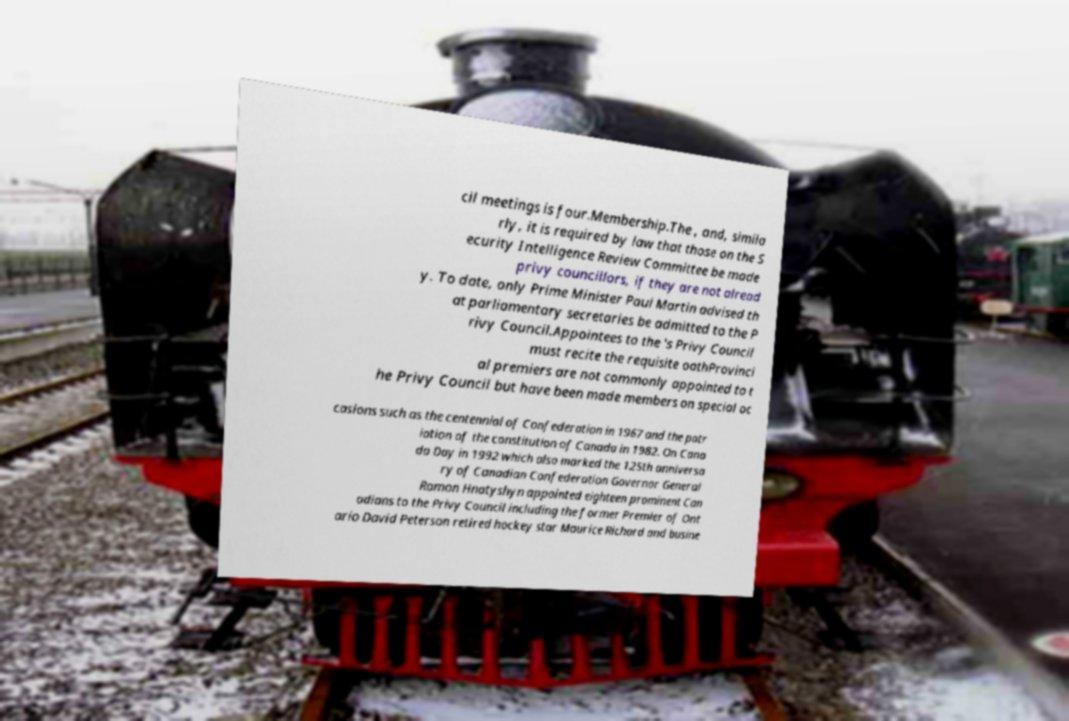Could you extract and type out the text from this image? cil meetings is four.Membership.The , and, simila rly, it is required by law that those on the S ecurity Intelligence Review Committee be made privy councillors, if they are not alread y. To date, only Prime Minister Paul Martin advised th at parliamentary secretaries be admitted to the P rivy Council.Appointees to the 's Privy Council must recite the requisite oathProvinci al premiers are not commonly appointed to t he Privy Council but have been made members on special oc casions such as the centennial of Confederation in 1967 and the patr iation of the constitution of Canada in 1982. On Cana da Day in 1992 which also marked the 125th anniversa ry of Canadian Confederation Governor General Ramon Hnatyshyn appointed eighteen prominent Can adians to the Privy Council including the former Premier of Ont ario David Peterson retired hockey star Maurice Richard and busine 